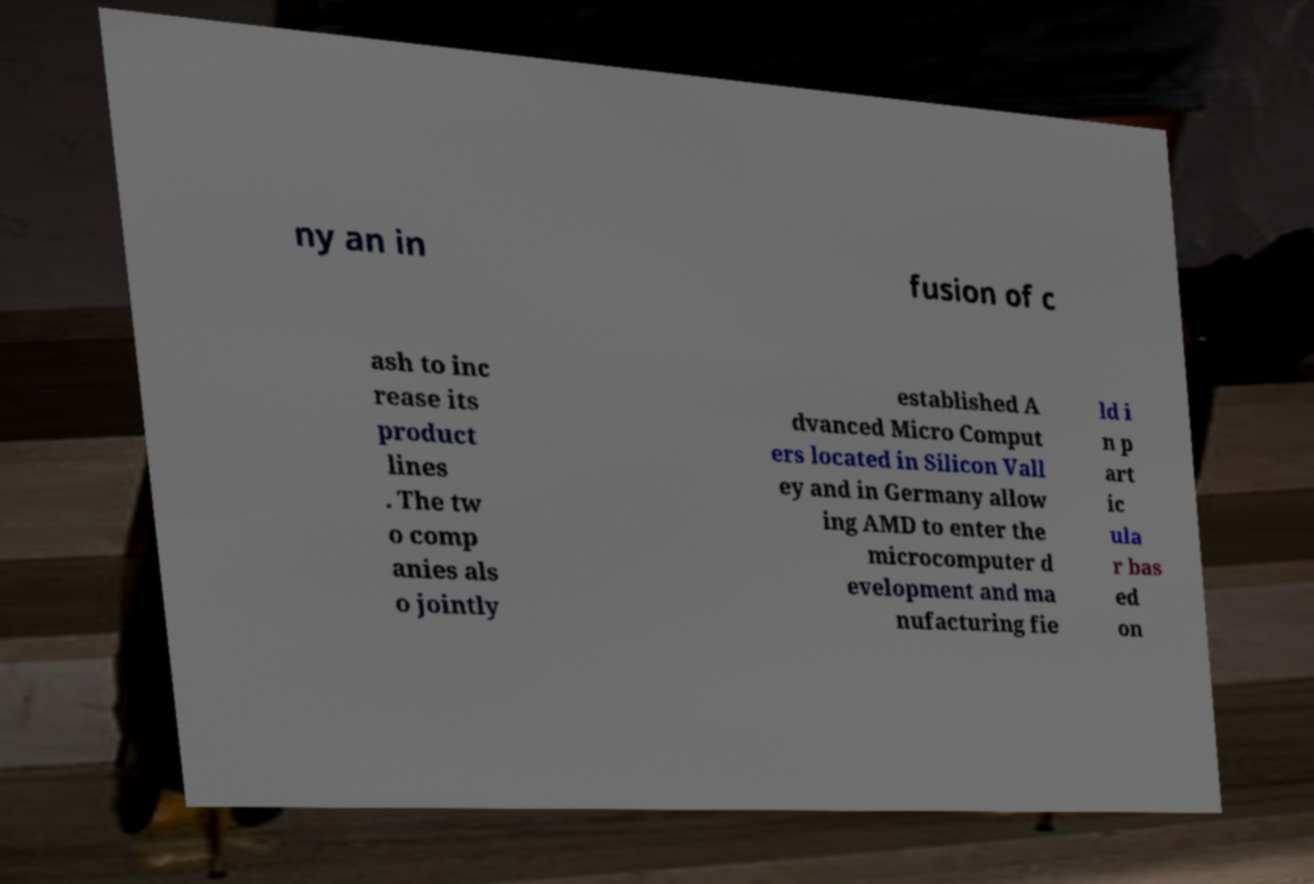Please identify and transcribe the text found in this image. ny an in fusion of c ash to inc rease its product lines . The tw o comp anies als o jointly established A dvanced Micro Comput ers located in Silicon Vall ey and in Germany allow ing AMD to enter the microcomputer d evelopment and ma nufacturing fie ld i n p art ic ula r bas ed on 